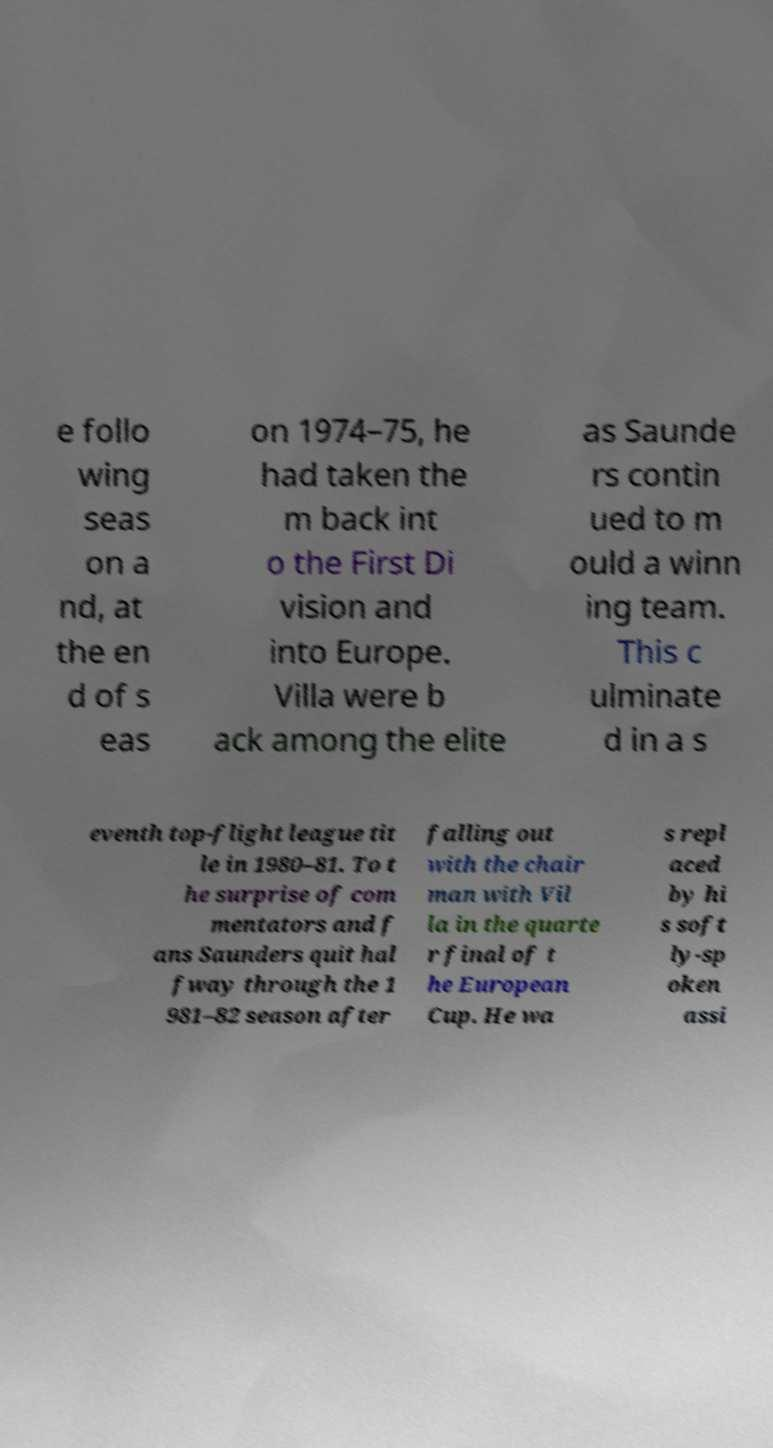There's text embedded in this image that I need extracted. Can you transcribe it verbatim? e follo wing seas on a nd, at the en d of s eas on 1974–75, he had taken the m back int o the First Di vision and into Europe. Villa were b ack among the elite as Saunde rs contin ued to m ould a winn ing team. This c ulminate d in a s eventh top-flight league tit le in 1980–81. To t he surprise of com mentators and f ans Saunders quit hal fway through the 1 981–82 season after falling out with the chair man with Vil la in the quarte r final of t he European Cup. He wa s repl aced by hi s soft ly-sp oken assi 